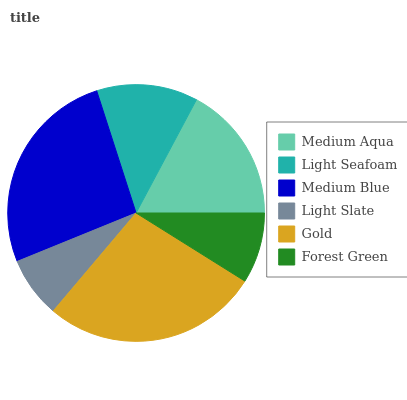Is Light Slate the minimum?
Answer yes or no. Yes. Is Gold the maximum?
Answer yes or no. Yes. Is Light Seafoam the minimum?
Answer yes or no. No. Is Light Seafoam the maximum?
Answer yes or no. No. Is Medium Aqua greater than Light Seafoam?
Answer yes or no. Yes. Is Light Seafoam less than Medium Aqua?
Answer yes or no. Yes. Is Light Seafoam greater than Medium Aqua?
Answer yes or no. No. Is Medium Aqua less than Light Seafoam?
Answer yes or no. No. Is Medium Aqua the high median?
Answer yes or no. Yes. Is Light Seafoam the low median?
Answer yes or no. Yes. Is Light Seafoam the high median?
Answer yes or no. No. Is Medium Aqua the low median?
Answer yes or no. No. 